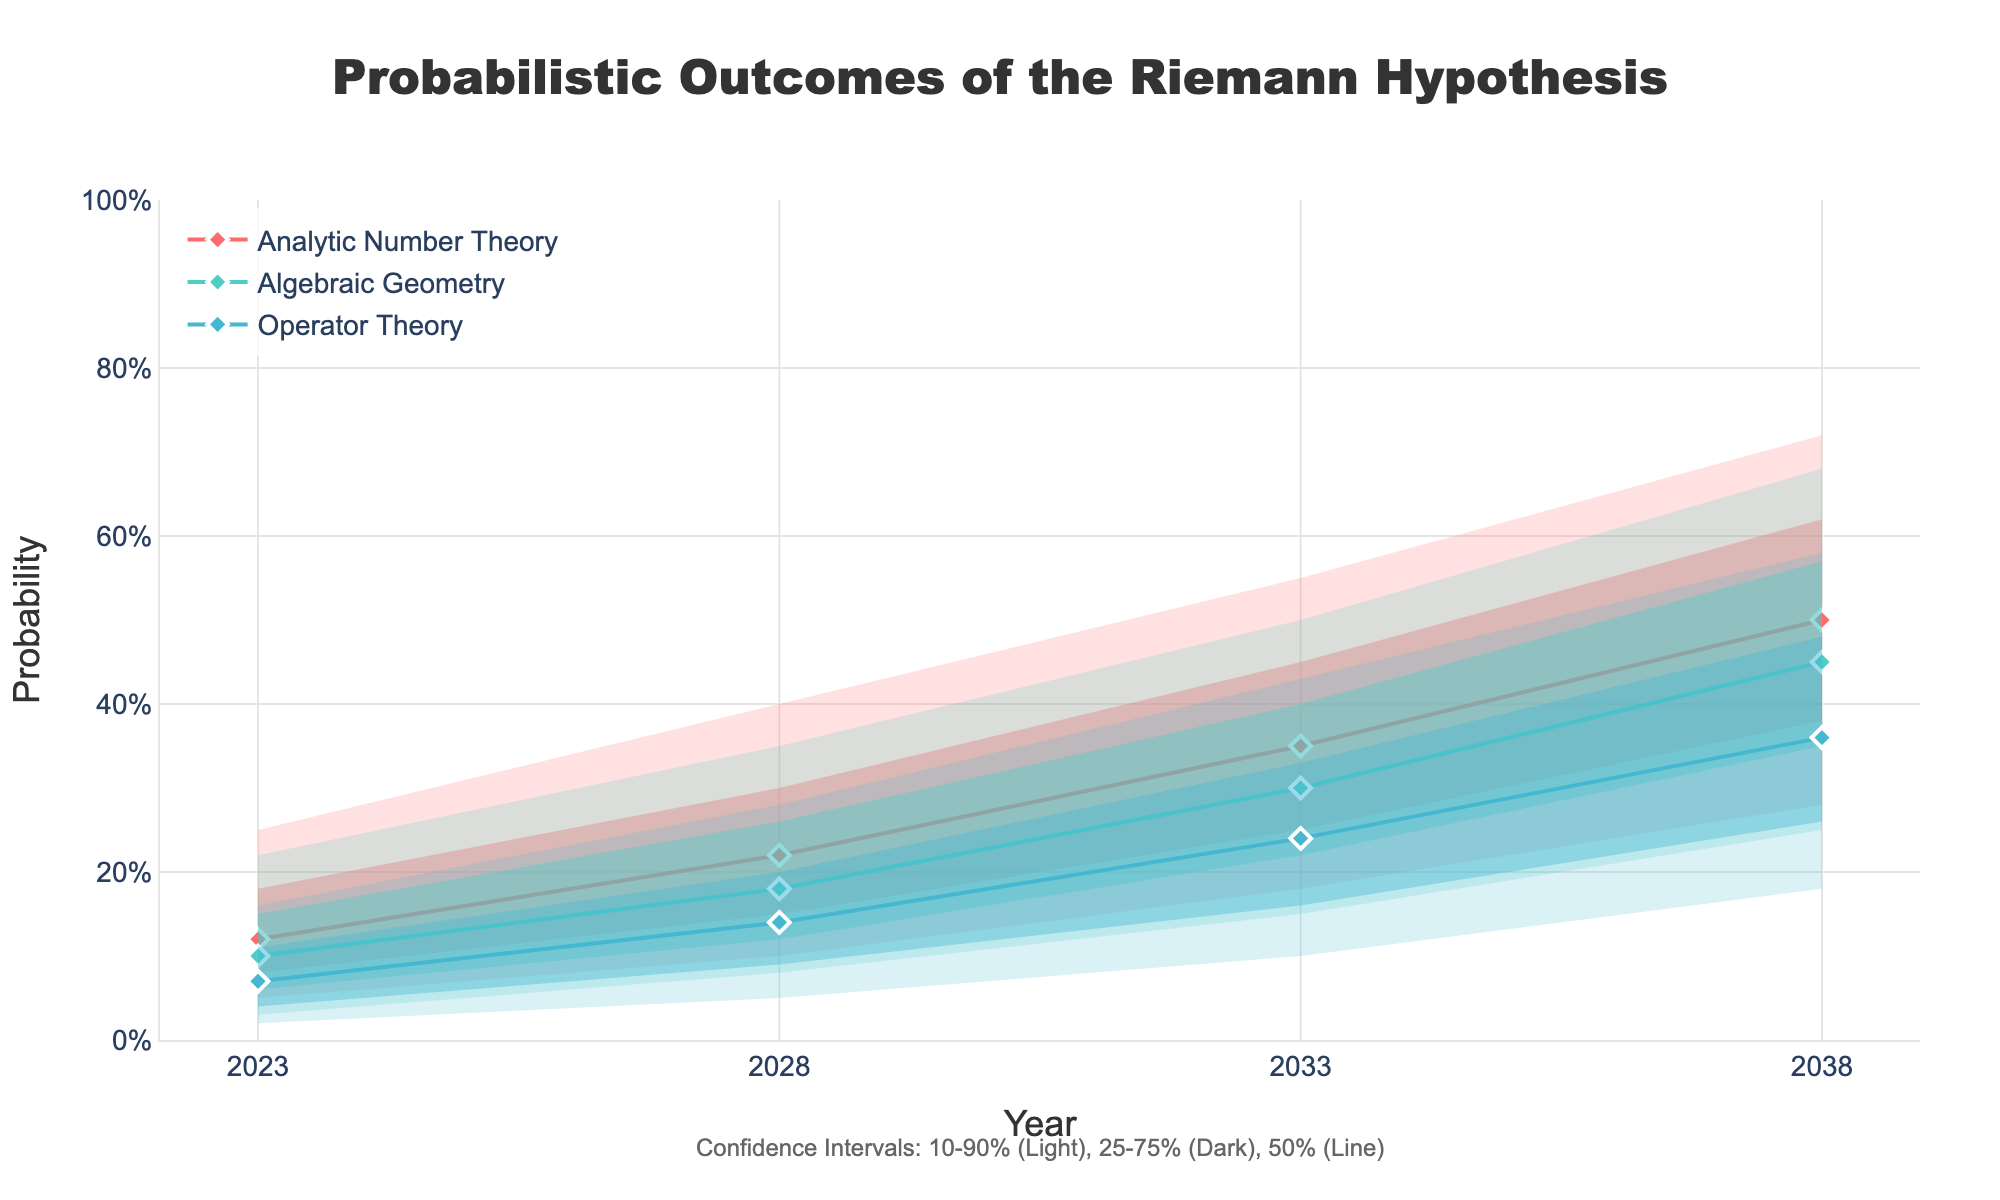How many approaches are used in the figure? The figure shows confidence intervals for various proof approaches with three different colors representing each approach. Each approach is listed multiple times across different years.
Answer: 3 What is the title of the figure? The title appears at the top of the chart in larger font, summarizing the content displayed in the plot.
Answer: Probabilistic Outcomes of the Riemann Hypothesis In 2028, what is the median probability for the Analytic Number Theory approach? The median value corresponds to the 50% probability value for Analytic Number Theory in 2028, found directly under the '50%' column.
Answer: 0.22 Compare the 90% probability values for Algebraic Geometry and Operator Theory in 2033. Which one is higher? Locate the 90% probability values for both Algebraic Geometry and Operator Theory in 2033 and compare them. Algebraic Geometry has 0.50, while Operator Theory shows 0.43.
Answer: Algebraic Geometry By how much does the median probability for Operator Theory change from 2023 to 2038? Identify the median values (50%) for Operator Theory in 2023 and 2038. Subtract the earlier value from the later one: 0.36 (2038) - 0.07 (2023).
Answer: 0.29 Which approach shows the highest median probability in 2038? Look at the 50% probability values for all approaches in 2038. Compare these values to determine which one is the highest.
Answer: Analytic Number Theory What are the confidence intervals indicated for each approach? The figure uses shaded areas to represent the 10-90%, 25-75%, and the line for the 50% confidence intervals for each approach.
Answer: 10-90%, 25-75%, 50% In which year does the Operator Theory approach have a 10% probability value of 0.10? Scan the 10% probability values for Operator Theory and identify the year when it reaches 0.10.
Answer: 2033 Is the probability trend for all approaches increasing or decreasing over time? By observing the general movement of the markers and lines from left to right, it’s evident whether the probabilities increase or decrease across the years for all approaches.
Answer: Increasing What is the range of probable values (from 10% to 90%) for Algebraic Geometry in 2023? Review the 10% and 90% values for Algebraic Geometry in 2023. The range is from the minimum (10%) to the maximum (90%).
Answer: 0.03 to 0.22 